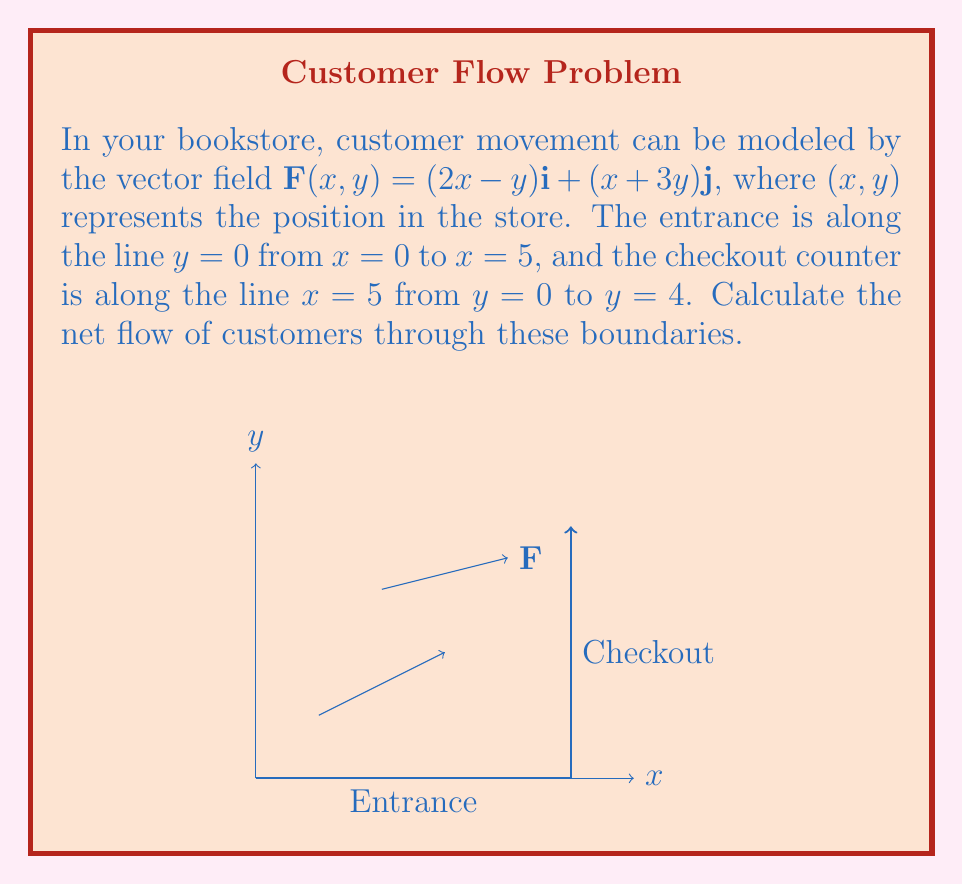Give your solution to this math problem. To solve this problem, we need to calculate the flux of the vector field across the given boundaries. The flux represents the net flow of customers through these boundaries.

Step 1: Set up the line integral for flux.
The flux is given by $\oint_C \mathbf{F} \cdot \mathbf{n} \, ds$, where $\mathbf{n}$ is the outward unit normal vector.

Step 2: Calculate flux through the entrance (C1).
Along $y=0$ from $x=0$ to $x=5$, $\mathbf{n} = -\mathbf{j}$.
$\int_0^5 \mathbf{F}(x,0) \cdot (-\mathbf{j}) \, dx = \int_0^5 -(x+3(0)) \, dx = -\frac{25}{2}$

Step 3: Calculate flux through the checkout counter (C2).
Along $x=5$ from $y=0$ to $y=4$, $\mathbf{n} = \mathbf{i}$.
$\int_0^4 \mathbf{F}(5,y) \cdot \mathbf{i} \, dy = \int_0^4 (2(5)-y) \, dy = 40 - 8 = 32$

Step 4: Sum the fluxes.
Total flux = Flux through C1 + Flux through C2
$= -\frac{25}{2} + 32 = \frac{39}{2}$

The positive result indicates a net outflow of customers, which makes sense as customers enter through the entrance and leave through the checkout.
Answer: $\frac{39}{2}$ 